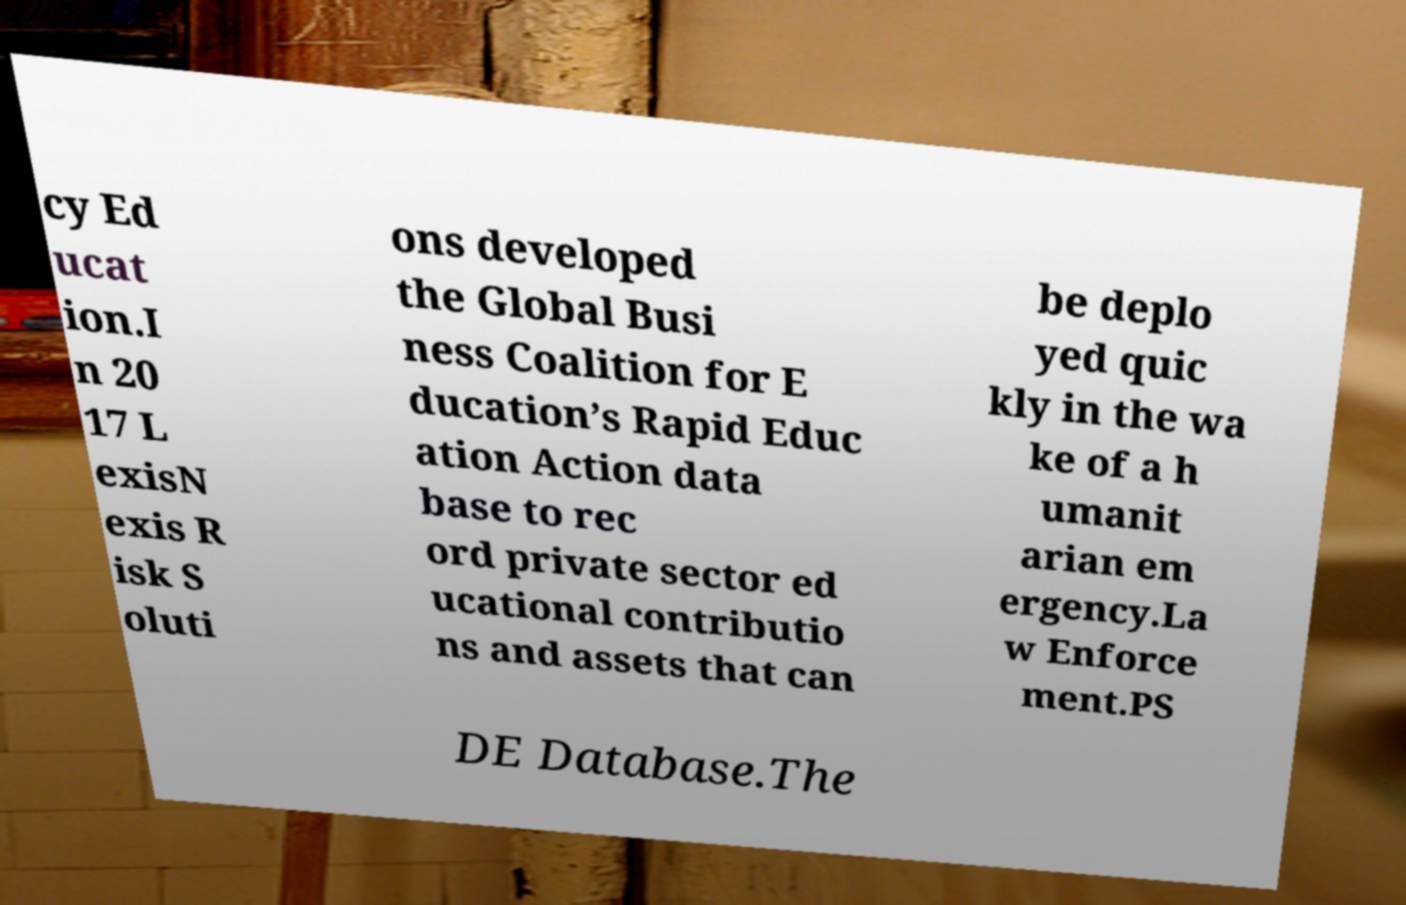Please identify and transcribe the text found in this image. cy Ed ucat ion.I n 20 17 L exisN exis R isk S oluti ons developed the Global Busi ness Coalition for E ducation’s Rapid Educ ation Action data base to rec ord private sector ed ucational contributio ns and assets that can be deplo yed quic kly in the wa ke of a h umanit arian em ergency.La w Enforce ment.PS DE Database.The 